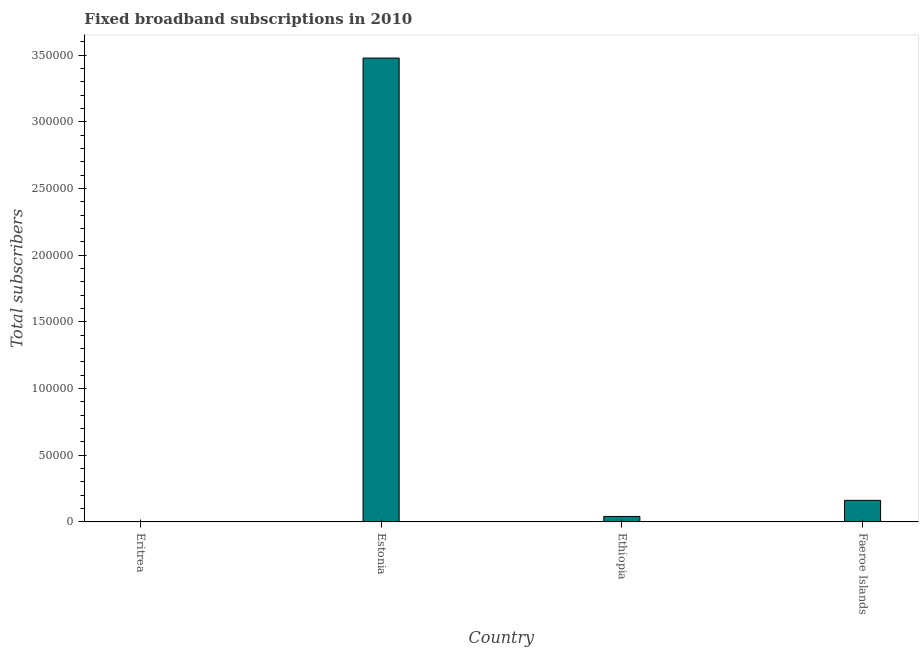Does the graph contain any zero values?
Offer a very short reply. No. What is the title of the graph?
Provide a short and direct response. Fixed broadband subscriptions in 2010. What is the label or title of the X-axis?
Provide a short and direct response. Country. What is the label or title of the Y-axis?
Your response must be concise. Total subscribers. What is the total number of fixed broadband subscriptions in Ethiopia?
Provide a short and direct response. 4107. Across all countries, what is the maximum total number of fixed broadband subscriptions?
Provide a succinct answer. 3.48e+05. Across all countries, what is the minimum total number of fixed broadband subscriptions?
Your response must be concise. 118. In which country was the total number of fixed broadband subscriptions maximum?
Provide a short and direct response. Estonia. In which country was the total number of fixed broadband subscriptions minimum?
Your answer should be compact. Eritrea. What is the sum of the total number of fixed broadband subscriptions?
Give a very brief answer. 3.68e+05. What is the difference between the total number of fixed broadband subscriptions in Ethiopia and Faeroe Islands?
Keep it short and to the point. -1.21e+04. What is the average total number of fixed broadband subscriptions per country?
Your answer should be compact. 9.21e+04. What is the median total number of fixed broadband subscriptions?
Provide a short and direct response. 1.01e+04. In how many countries, is the total number of fixed broadband subscriptions greater than 70000 ?
Your answer should be compact. 1. What is the ratio of the total number of fixed broadband subscriptions in Eritrea to that in Faeroe Islands?
Provide a succinct answer. 0.01. What is the difference between the highest and the second highest total number of fixed broadband subscriptions?
Offer a terse response. 3.32e+05. What is the difference between the highest and the lowest total number of fixed broadband subscriptions?
Your answer should be compact. 3.48e+05. How many bars are there?
Your answer should be compact. 4. Are all the bars in the graph horizontal?
Your answer should be compact. No. Are the values on the major ticks of Y-axis written in scientific E-notation?
Ensure brevity in your answer.  No. What is the Total subscribers in Eritrea?
Give a very brief answer. 118. What is the Total subscribers of Estonia?
Ensure brevity in your answer.  3.48e+05. What is the Total subscribers of Ethiopia?
Keep it short and to the point. 4107. What is the Total subscribers in Faeroe Islands?
Provide a succinct answer. 1.62e+04. What is the difference between the Total subscribers in Eritrea and Estonia?
Make the answer very short. -3.48e+05. What is the difference between the Total subscribers in Eritrea and Ethiopia?
Make the answer very short. -3989. What is the difference between the Total subscribers in Eritrea and Faeroe Islands?
Your answer should be very brief. -1.61e+04. What is the difference between the Total subscribers in Estonia and Ethiopia?
Offer a very short reply. 3.44e+05. What is the difference between the Total subscribers in Estonia and Faeroe Islands?
Provide a succinct answer. 3.32e+05. What is the difference between the Total subscribers in Ethiopia and Faeroe Islands?
Your answer should be very brief. -1.21e+04. What is the ratio of the Total subscribers in Eritrea to that in Ethiopia?
Give a very brief answer. 0.03. What is the ratio of the Total subscribers in Eritrea to that in Faeroe Islands?
Your answer should be very brief. 0.01. What is the ratio of the Total subscribers in Estonia to that in Ethiopia?
Make the answer very short. 84.7. What is the ratio of the Total subscribers in Estonia to that in Faeroe Islands?
Keep it short and to the point. 21.5. What is the ratio of the Total subscribers in Ethiopia to that in Faeroe Islands?
Give a very brief answer. 0.25. 